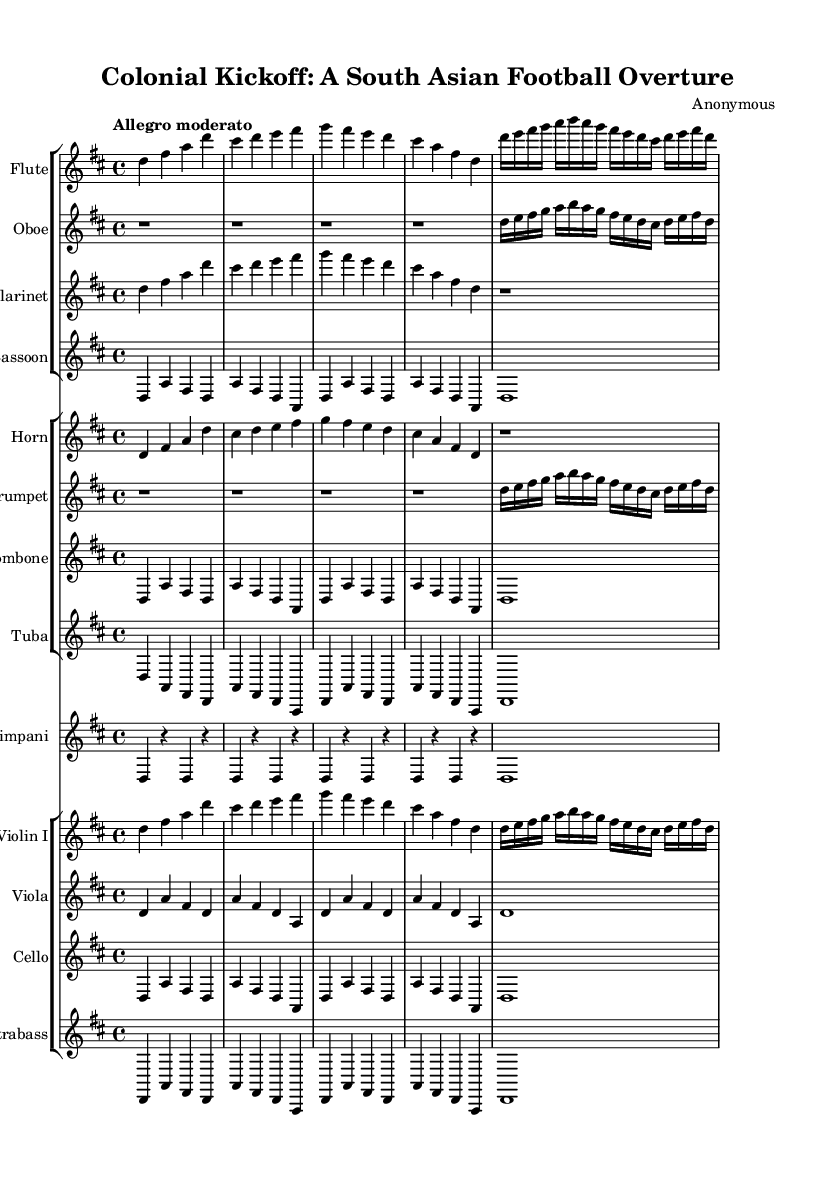What is the key signature of this music? The key signature is indicated in the first measure of the score and shows two sharps, which correspond to F# and C#, indicating that it is in D major.
Answer: D major What is the time signature of this piece? The time signature appears at the beginning of the score and indicates a 4/4 time, meaning there are four beats in each measure and the quarter note gets one beat.
Answer: 4/4 What is the tempo marking for the piece? The tempo marking is written above the staff at the beginning of the score as "Allegro moderato," indicating a moderate speed that is lively.
Answer: Allegro moderato How many different instrument groups are present in the score? Analyzing the score, we can identify three distinct groups: woodwinds, brass, and strings, which include flute, oboe, clarinet, bassoon, horn, trumpet, trombone, tuba, timpani, violin, viola, cello, and contrabass.
Answer: Three Which instrument has a rest for the entire first section? In the score, the oboe part shows four whole rests at the beginning, signifying that it does not play during that section while other instruments do.
Answer: Oboe What is the predominant theme in the violins during the first section? The violin section plays a continuous line of ascending and descending notes primarily based on the root notes of the key, creating a melodic theme that complements the rhythm, representative of the spirited nature of the piece reflecting colonial influences on football.
Answer: Ascending and descending melody Which instrument plays the longest note in the score? The bassoon, tuba, and timpani all hold a whole note in the score, but it is the bassoon part that features a retained whole note throughout the entire section, indicating a sustained presence.
Answer: Bassoon 